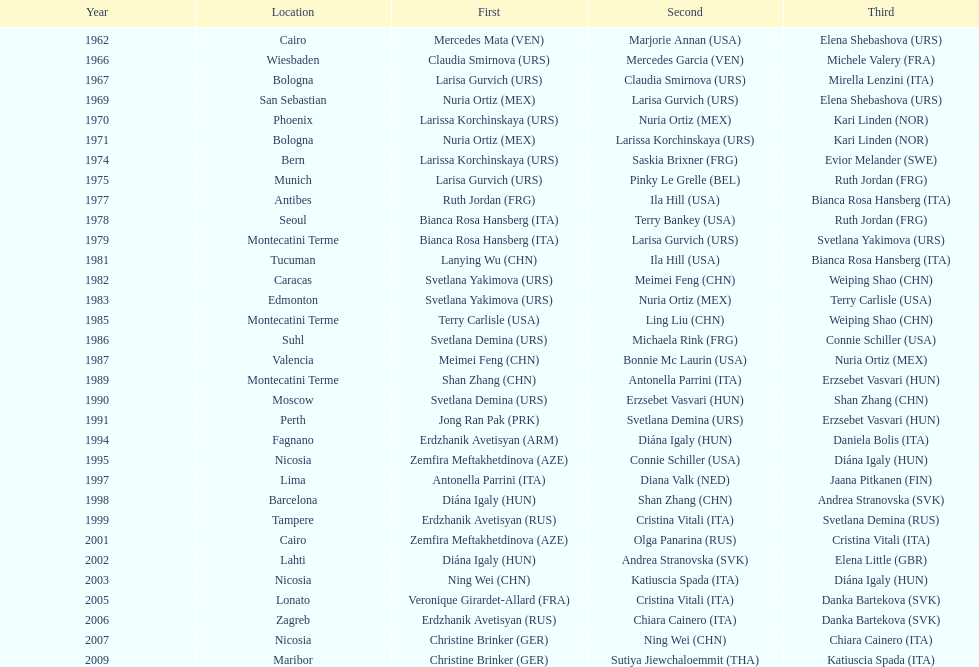Which country has the most bronze medals? Italy. 